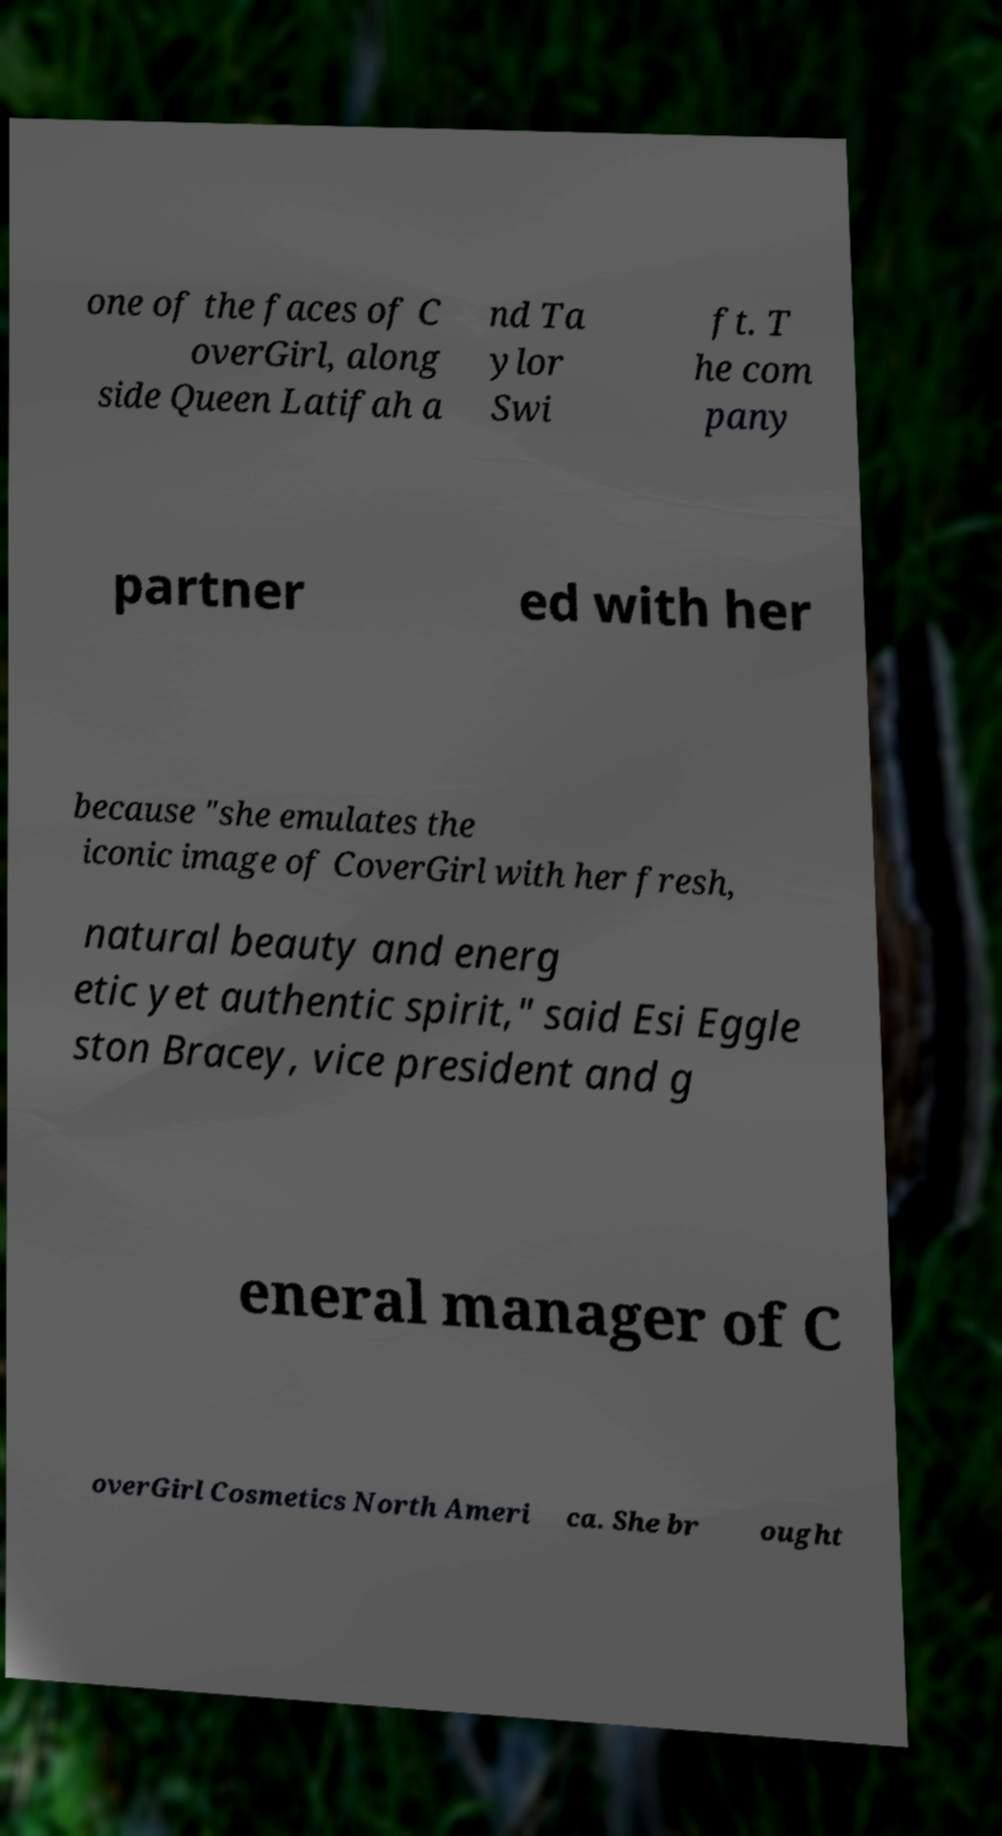There's text embedded in this image that I need extracted. Can you transcribe it verbatim? one of the faces of C overGirl, along side Queen Latifah a nd Ta ylor Swi ft. T he com pany partner ed with her because "she emulates the iconic image of CoverGirl with her fresh, natural beauty and energ etic yet authentic spirit," said Esi Eggle ston Bracey, vice president and g eneral manager of C overGirl Cosmetics North Ameri ca. She br ought 